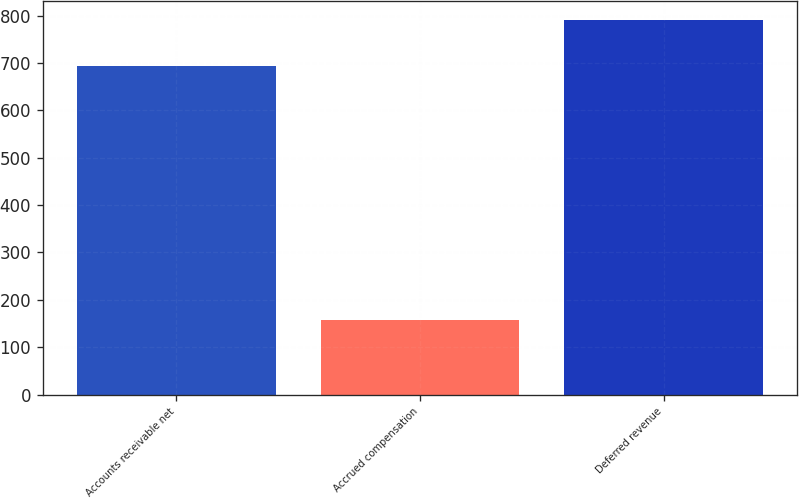Convert chart to OTSL. <chart><loc_0><loc_0><loc_500><loc_500><bar_chart><fcel>Accounts receivable net<fcel>Accrued compensation<fcel>Deferred revenue<nl><fcel>693.5<fcel>157.4<fcel>790.8<nl></chart> 